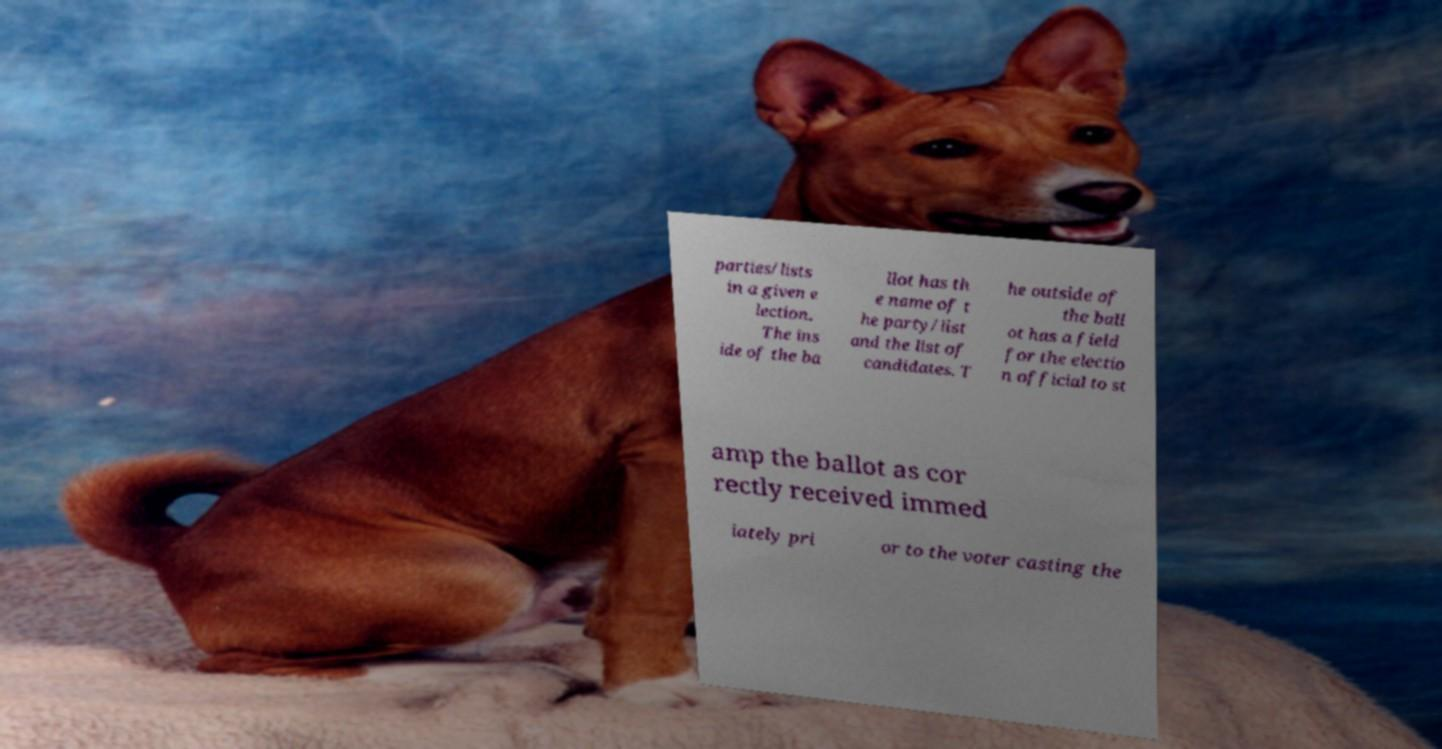For documentation purposes, I need the text within this image transcribed. Could you provide that? parties/lists in a given e lection. The ins ide of the ba llot has th e name of t he party/list and the list of candidates. T he outside of the ball ot has a field for the electio n official to st amp the ballot as cor rectly received immed iately pri or to the voter casting the 